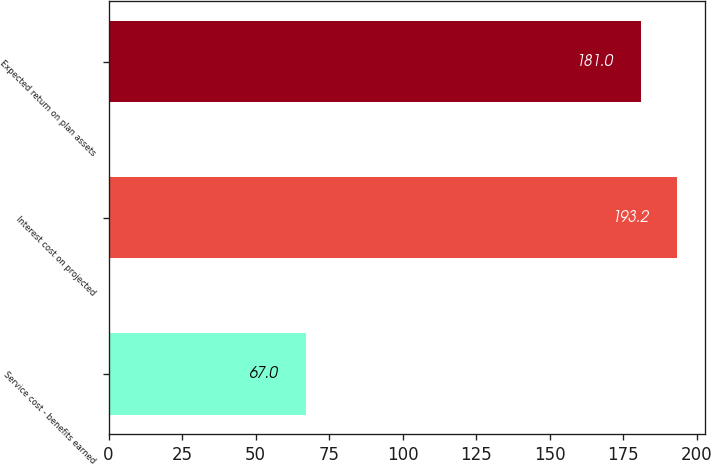Convert chart. <chart><loc_0><loc_0><loc_500><loc_500><bar_chart><fcel>Service cost - benefits earned<fcel>Interest cost on projected<fcel>Expected return on plan assets<nl><fcel>67<fcel>193.2<fcel>181<nl></chart> 